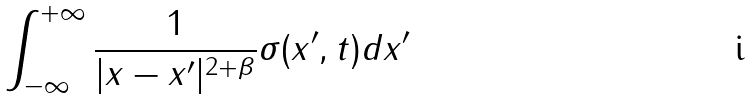<formula> <loc_0><loc_0><loc_500><loc_500>\int _ { - \infty } ^ { + \infty } \frac { 1 } { | x - x ^ { \prime } | ^ { 2 + \beta } } \sigma ( x ^ { \prime } , t ) d x ^ { \prime }</formula> 